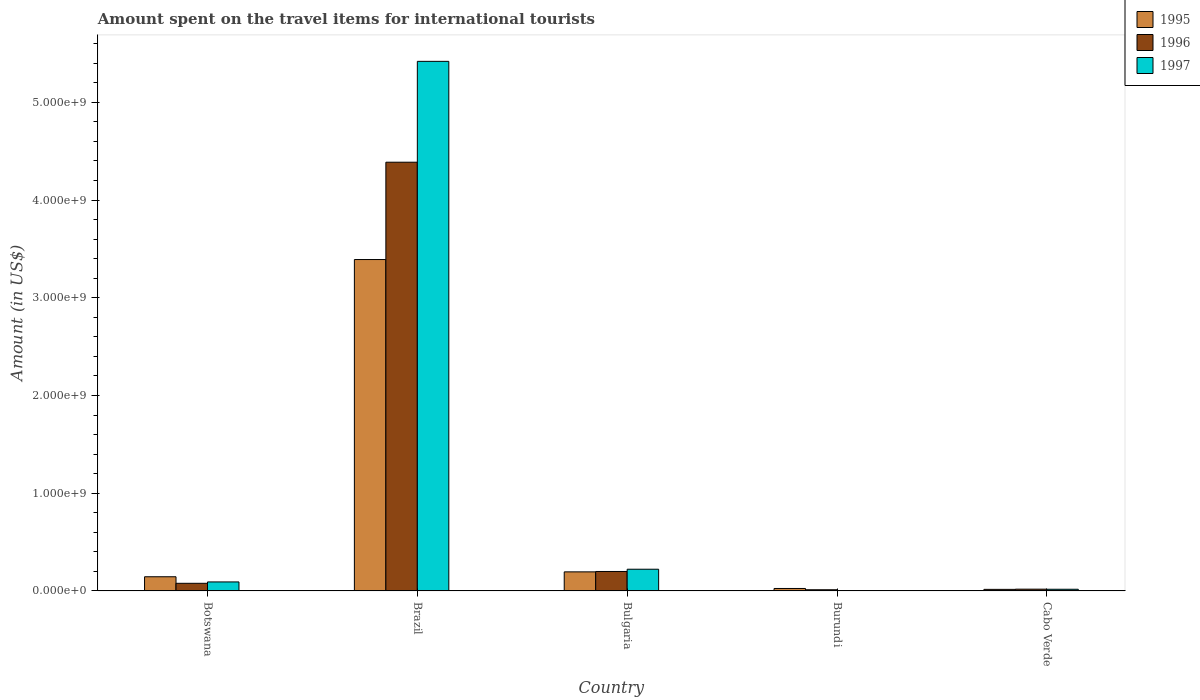How many different coloured bars are there?
Keep it short and to the point. 3. Are the number of bars on each tick of the X-axis equal?
Keep it short and to the point. Yes. How many bars are there on the 4th tick from the left?
Offer a terse response. 3. What is the label of the 4th group of bars from the left?
Offer a terse response. Burundi. In how many cases, is the number of bars for a given country not equal to the number of legend labels?
Make the answer very short. 0. What is the amount spent on the travel items for international tourists in 1996 in Burundi?
Provide a short and direct response. 1.20e+07. Across all countries, what is the maximum amount spent on the travel items for international tourists in 1997?
Your response must be concise. 5.42e+09. In which country was the amount spent on the travel items for international tourists in 1996 minimum?
Make the answer very short. Burundi. What is the total amount spent on the travel items for international tourists in 1997 in the graph?
Ensure brevity in your answer.  5.75e+09. What is the difference between the amount spent on the travel items for international tourists in 1996 in Botswana and that in Bulgaria?
Provide a succinct answer. -1.21e+08. What is the difference between the amount spent on the travel items for international tourists in 1995 in Burundi and the amount spent on the travel items for international tourists in 1997 in Botswana?
Your response must be concise. -6.70e+07. What is the average amount spent on the travel items for international tourists in 1995 per country?
Your answer should be very brief. 7.54e+08. What is the difference between the amount spent on the travel items for international tourists of/in 1997 and amount spent on the travel items for international tourists of/in 1996 in Bulgaria?
Offer a terse response. 2.30e+07. In how many countries, is the amount spent on the travel items for international tourists in 1995 greater than 2200000000 US$?
Offer a terse response. 1. What is the ratio of the amount spent on the travel items for international tourists in 1995 in Brazil to that in Burundi?
Provide a short and direct response. 135.64. Is the difference between the amount spent on the travel items for international tourists in 1997 in Brazil and Bulgaria greater than the difference between the amount spent on the travel items for international tourists in 1996 in Brazil and Bulgaria?
Provide a short and direct response. Yes. What is the difference between the highest and the second highest amount spent on the travel items for international tourists in 1995?
Your answer should be very brief. 3.25e+09. What is the difference between the highest and the lowest amount spent on the travel items for international tourists in 1995?
Provide a succinct answer. 3.38e+09. In how many countries, is the amount spent on the travel items for international tourists in 1995 greater than the average amount spent on the travel items for international tourists in 1995 taken over all countries?
Your answer should be compact. 1. What does the 3rd bar from the left in Cabo Verde represents?
Your answer should be compact. 1997. What does the 2nd bar from the right in Cabo Verde represents?
Offer a terse response. 1996. Is it the case that in every country, the sum of the amount spent on the travel items for international tourists in 1997 and amount spent on the travel items for international tourists in 1996 is greater than the amount spent on the travel items for international tourists in 1995?
Your answer should be compact. No. How many bars are there?
Your response must be concise. 15. Are all the bars in the graph horizontal?
Your answer should be very brief. No. How many countries are there in the graph?
Provide a short and direct response. 5. What is the difference between two consecutive major ticks on the Y-axis?
Ensure brevity in your answer.  1.00e+09. Does the graph contain grids?
Offer a very short reply. No. How are the legend labels stacked?
Keep it short and to the point. Vertical. What is the title of the graph?
Offer a very short reply. Amount spent on the travel items for international tourists. Does "2010" appear as one of the legend labels in the graph?
Offer a very short reply. No. What is the label or title of the Y-axis?
Offer a very short reply. Amount (in US$). What is the Amount (in US$) in 1995 in Botswana?
Your answer should be compact. 1.45e+08. What is the Amount (in US$) of 1996 in Botswana?
Provide a succinct answer. 7.80e+07. What is the Amount (in US$) of 1997 in Botswana?
Ensure brevity in your answer.  9.20e+07. What is the Amount (in US$) of 1995 in Brazil?
Give a very brief answer. 3.39e+09. What is the Amount (in US$) in 1996 in Brazil?
Make the answer very short. 4.39e+09. What is the Amount (in US$) in 1997 in Brazil?
Your answer should be very brief. 5.42e+09. What is the Amount (in US$) in 1995 in Bulgaria?
Offer a terse response. 1.95e+08. What is the Amount (in US$) in 1996 in Bulgaria?
Give a very brief answer. 1.99e+08. What is the Amount (in US$) of 1997 in Bulgaria?
Ensure brevity in your answer.  2.22e+08. What is the Amount (in US$) in 1995 in Burundi?
Offer a very short reply. 2.50e+07. What is the Amount (in US$) of 1996 in Burundi?
Provide a succinct answer. 1.20e+07. What is the Amount (in US$) in 1997 in Burundi?
Your response must be concise. 4.00e+06. What is the Amount (in US$) of 1995 in Cabo Verde?
Provide a short and direct response. 1.60e+07. What is the Amount (in US$) of 1996 in Cabo Verde?
Your answer should be compact. 1.80e+07. What is the Amount (in US$) of 1997 in Cabo Verde?
Make the answer very short. 1.70e+07. Across all countries, what is the maximum Amount (in US$) of 1995?
Your answer should be very brief. 3.39e+09. Across all countries, what is the maximum Amount (in US$) of 1996?
Make the answer very short. 4.39e+09. Across all countries, what is the maximum Amount (in US$) in 1997?
Keep it short and to the point. 5.42e+09. Across all countries, what is the minimum Amount (in US$) of 1995?
Offer a terse response. 1.60e+07. Across all countries, what is the minimum Amount (in US$) in 1996?
Your response must be concise. 1.20e+07. What is the total Amount (in US$) in 1995 in the graph?
Offer a very short reply. 3.77e+09. What is the total Amount (in US$) of 1996 in the graph?
Ensure brevity in your answer.  4.69e+09. What is the total Amount (in US$) in 1997 in the graph?
Keep it short and to the point. 5.75e+09. What is the difference between the Amount (in US$) in 1995 in Botswana and that in Brazil?
Your answer should be compact. -3.25e+09. What is the difference between the Amount (in US$) of 1996 in Botswana and that in Brazil?
Ensure brevity in your answer.  -4.31e+09. What is the difference between the Amount (in US$) in 1997 in Botswana and that in Brazil?
Offer a very short reply. -5.33e+09. What is the difference between the Amount (in US$) in 1995 in Botswana and that in Bulgaria?
Offer a very short reply. -5.00e+07. What is the difference between the Amount (in US$) in 1996 in Botswana and that in Bulgaria?
Provide a short and direct response. -1.21e+08. What is the difference between the Amount (in US$) of 1997 in Botswana and that in Bulgaria?
Your answer should be compact. -1.30e+08. What is the difference between the Amount (in US$) of 1995 in Botswana and that in Burundi?
Provide a short and direct response. 1.20e+08. What is the difference between the Amount (in US$) in 1996 in Botswana and that in Burundi?
Provide a short and direct response. 6.60e+07. What is the difference between the Amount (in US$) in 1997 in Botswana and that in Burundi?
Provide a succinct answer. 8.80e+07. What is the difference between the Amount (in US$) in 1995 in Botswana and that in Cabo Verde?
Your answer should be compact. 1.29e+08. What is the difference between the Amount (in US$) of 1996 in Botswana and that in Cabo Verde?
Give a very brief answer. 6.00e+07. What is the difference between the Amount (in US$) in 1997 in Botswana and that in Cabo Verde?
Your response must be concise. 7.50e+07. What is the difference between the Amount (in US$) of 1995 in Brazil and that in Bulgaria?
Provide a short and direct response. 3.20e+09. What is the difference between the Amount (in US$) in 1996 in Brazil and that in Bulgaria?
Your answer should be compact. 4.19e+09. What is the difference between the Amount (in US$) in 1997 in Brazil and that in Bulgaria?
Make the answer very short. 5.20e+09. What is the difference between the Amount (in US$) in 1995 in Brazil and that in Burundi?
Your answer should be very brief. 3.37e+09. What is the difference between the Amount (in US$) in 1996 in Brazil and that in Burundi?
Your response must be concise. 4.38e+09. What is the difference between the Amount (in US$) in 1997 in Brazil and that in Burundi?
Your response must be concise. 5.42e+09. What is the difference between the Amount (in US$) of 1995 in Brazil and that in Cabo Verde?
Offer a very short reply. 3.38e+09. What is the difference between the Amount (in US$) in 1996 in Brazil and that in Cabo Verde?
Make the answer very short. 4.37e+09. What is the difference between the Amount (in US$) in 1997 in Brazil and that in Cabo Verde?
Provide a succinct answer. 5.40e+09. What is the difference between the Amount (in US$) in 1995 in Bulgaria and that in Burundi?
Provide a short and direct response. 1.70e+08. What is the difference between the Amount (in US$) of 1996 in Bulgaria and that in Burundi?
Make the answer very short. 1.87e+08. What is the difference between the Amount (in US$) in 1997 in Bulgaria and that in Burundi?
Provide a succinct answer. 2.18e+08. What is the difference between the Amount (in US$) in 1995 in Bulgaria and that in Cabo Verde?
Make the answer very short. 1.79e+08. What is the difference between the Amount (in US$) of 1996 in Bulgaria and that in Cabo Verde?
Keep it short and to the point. 1.81e+08. What is the difference between the Amount (in US$) in 1997 in Bulgaria and that in Cabo Verde?
Provide a short and direct response. 2.05e+08. What is the difference between the Amount (in US$) in 1995 in Burundi and that in Cabo Verde?
Keep it short and to the point. 9.00e+06. What is the difference between the Amount (in US$) of 1996 in Burundi and that in Cabo Verde?
Offer a terse response. -6.00e+06. What is the difference between the Amount (in US$) in 1997 in Burundi and that in Cabo Verde?
Provide a short and direct response. -1.30e+07. What is the difference between the Amount (in US$) of 1995 in Botswana and the Amount (in US$) of 1996 in Brazil?
Give a very brief answer. -4.24e+09. What is the difference between the Amount (in US$) of 1995 in Botswana and the Amount (in US$) of 1997 in Brazil?
Ensure brevity in your answer.  -5.27e+09. What is the difference between the Amount (in US$) of 1996 in Botswana and the Amount (in US$) of 1997 in Brazil?
Your answer should be very brief. -5.34e+09. What is the difference between the Amount (in US$) of 1995 in Botswana and the Amount (in US$) of 1996 in Bulgaria?
Keep it short and to the point. -5.40e+07. What is the difference between the Amount (in US$) of 1995 in Botswana and the Amount (in US$) of 1997 in Bulgaria?
Provide a succinct answer. -7.70e+07. What is the difference between the Amount (in US$) of 1996 in Botswana and the Amount (in US$) of 1997 in Bulgaria?
Your answer should be very brief. -1.44e+08. What is the difference between the Amount (in US$) of 1995 in Botswana and the Amount (in US$) of 1996 in Burundi?
Your answer should be compact. 1.33e+08. What is the difference between the Amount (in US$) of 1995 in Botswana and the Amount (in US$) of 1997 in Burundi?
Provide a short and direct response. 1.41e+08. What is the difference between the Amount (in US$) of 1996 in Botswana and the Amount (in US$) of 1997 in Burundi?
Make the answer very short. 7.40e+07. What is the difference between the Amount (in US$) in 1995 in Botswana and the Amount (in US$) in 1996 in Cabo Verde?
Offer a terse response. 1.27e+08. What is the difference between the Amount (in US$) of 1995 in Botswana and the Amount (in US$) of 1997 in Cabo Verde?
Keep it short and to the point. 1.28e+08. What is the difference between the Amount (in US$) in 1996 in Botswana and the Amount (in US$) in 1997 in Cabo Verde?
Make the answer very short. 6.10e+07. What is the difference between the Amount (in US$) in 1995 in Brazil and the Amount (in US$) in 1996 in Bulgaria?
Keep it short and to the point. 3.19e+09. What is the difference between the Amount (in US$) of 1995 in Brazil and the Amount (in US$) of 1997 in Bulgaria?
Provide a succinct answer. 3.17e+09. What is the difference between the Amount (in US$) of 1996 in Brazil and the Amount (in US$) of 1997 in Bulgaria?
Offer a terse response. 4.16e+09. What is the difference between the Amount (in US$) in 1995 in Brazil and the Amount (in US$) in 1996 in Burundi?
Keep it short and to the point. 3.38e+09. What is the difference between the Amount (in US$) of 1995 in Brazil and the Amount (in US$) of 1997 in Burundi?
Give a very brief answer. 3.39e+09. What is the difference between the Amount (in US$) in 1996 in Brazil and the Amount (in US$) in 1997 in Burundi?
Give a very brief answer. 4.38e+09. What is the difference between the Amount (in US$) in 1995 in Brazil and the Amount (in US$) in 1996 in Cabo Verde?
Your answer should be compact. 3.37e+09. What is the difference between the Amount (in US$) in 1995 in Brazil and the Amount (in US$) in 1997 in Cabo Verde?
Provide a succinct answer. 3.37e+09. What is the difference between the Amount (in US$) in 1996 in Brazil and the Amount (in US$) in 1997 in Cabo Verde?
Offer a terse response. 4.37e+09. What is the difference between the Amount (in US$) in 1995 in Bulgaria and the Amount (in US$) in 1996 in Burundi?
Make the answer very short. 1.83e+08. What is the difference between the Amount (in US$) of 1995 in Bulgaria and the Amount (in US$) of 1997 in Burundi?
Provide a succinct answer. 1.91e+08. What is the difference between the Amount (in US$) of 1996 in Bulgaria and the Amount (in US$) of 1997 in Burundi?
Offer a very short reply. 1.95e+08. What is the difference between the Amount (in US$) in 1995 in Bulgaria and the Amount (in US$) in 1996 in Cabo Verde?
Keep it short and to the point. 1.77e+08. What is the difference between the Amount (in US$) of 1995 in Bulgaria and the Amount (in US$) of 1997 in Cabo Verde?
Provide a succinct answer. 1.78e+08. What is the difference between the Amount (in US$) of 1996 in Bulgaria and the Amount (in US$) of 1997 in Cabo Verde?
Ensure brevity in your answer.  1.82e+08. What is the difference between the Amount (in US$) of 1996 in Burundi and the Amount (in US$) of 1997 in Cabo Verde?
Make the answer very short. -5.00e+06. What is the average Amount (in US$) in 1995 per country?
Give a very brief answer. 7.54e+08. What is the average Amount (in US$) of 1996 per country?
Your response must be concise. 9.39e+08. What is the average Amount (in US$) of 1997 per country?
Your answer should be compact. 1.15e+09. What is the difference between the Amount (in US$) in 1995 and Amount (in US$) in 1996 in Botswana?
Keep it short and to the point. 6.70e+07. What is the difference between the Amount (in US$) of 1995 and Amount (in US$) of 1997 in Botswana?
Provide a succinct answer. 5.30e+07. What is the difference between the Amount (in US$) in 1996 and Amount (in US$) in 1997 in Botswana?
Provide a succinct answer. -1.40e+07. What is the difference between the Amount (in US$) of 1995 and Amount (in US$) of 1996 in Brazil?
Your answer should be compact. -9.96e+08. What is the difference between the Amount (in US$) in 1995 and Amount (in US$) in 1997 in Brazil?
Your answer should be compact. -2.03e+09. What is the difference between the Amount (in US$) of 1996 and Amount (in US$) of 1997 in Brazil?
Give a very brief answer. -1.03e+09. What is the difference between the Amount (in US$) in 1995 and Amount (in US$) in 1996 in Bulgaria?
Your answer should be compact. -4.00e+06. What is the difference between the Amount (in US$) of 1995 and Amount (in US$) of 1997 in Bulgaria?
Your answer should be very brief. -2.70e+07. What is the difference between the Amount (in US$) in 1996 and Amount (in US$) in 1997 in Bulgaria?
Offer a terse response. -2.30e+07. What is the difference between the Amount (in US$) of 1995 and Amount (in US$) of 1996 in Burundi?
Provide a short and direct response. 1.30e+07. What is the difference between the Amount (in US$) in 1995 and Amount (in US$) in 1997 in Burundi?
Offer a very short reply. 2.10e+07. What is the difference between the Amount (in US$) in 1995 and Amount (in US$) in 1996 in Cabo Verde?
Keep it short and to the point. -2.00e+06. What is the difference between the Amount (in US$) in 1996 and Amount (in US$) in 1997 in Cabo Verde?
Ensure brevity in your answer.  1.00e+06. What is the ratio of the Amount (in US$) in 1995 in Botswana to that in Brazil?
Offer a terse response. 0.04. What is the ratio of the Amount (in US$) of 1996 in Botswana to that in Brazil?
Make the answer very short. 0.02. What is the ratio of the Amount (in US$) in 1997 in Botswana to that in Brazil?
Provide a short and direct response. 0.02. What is the ratio of the Amount (in US$) in 1995 in Botswana to that in Bulgaria?
Ensure brevity in your answer.  0.74. What is the ratio of the Amount (in US$) in 1996 in Botswana to that in Bulgaria?
Your answer should be very brief. 0.39. What is the ratio of the Amount (in US$) of 1997 in Botswana to that in Bulgaria?
Offer a terse response. 0.41. What is the ratio of the Amount (in US$) in 1995 in Botswana to that in Burundi?
Give a very brief answer. 5.8. What is the ratio of the Amount (in US$) in 1997 in Botswana to that in Burundi?
Give a very brief answer. 23. What is the ratio of the Amount (in US$) in 1995 in Botswana to that in Cabo Verde?
Ensure brevity in your answer.  9.06. What is the ratio of the Amount (in US$) in 1996 in Botswana to that in Cabo Verde?
Provide a short and direct response. 4.33. What is the ratio of the Amount (in US$) in 1997 in Botswana to that in Cabo Verde?
Provide a short and direct response. 5.41. What is the ratio of the Amount (in US$) of 1995 in Brazil to that in Bulgaria?
Keep it short and to the point. 17.39. What is the ratio of the Amount (in US$) of 1996 in Brazil to that in Bulgaria?
Offer a terse response. 22.05. What is the ratio of the Amount (in US$) of 1997 in Brazil to that in Bulgaria?
Offer a very short reply. 24.41. What is the ratio of the Amount (in US$) in 1995 in Brazil to that in Burundi?
Ensure brevity in your answer.  135.64. What is the ratio of the Amount (in US$) of 1996 in Brazil to that in Burundi?
Your response must be concise. 365.58. What is the ratio of the Amount (in US$) in 1997 in Brazil to that in Burundi?
Your answer should be very brief. 1354.75. What is the ratio of the Amount (in US$) of 1995 in Brazil to that in Cabo Verde?
Provide a short and direct response. 211.94. What is the ratio of the Amount (in US$) of 1996 in Brazil to that in Cabo Verde?
Ensure brevity in your answer.  243.72. What is the ratio of the Amount (in US$) of 1997 in Brazil to that in Cabo Verde?
Your answer should be compact. 318.76. What is the ratio of the Amount (in US$) of 1996 in Bulgaria to that in Burundi?
Keep it short and to the point. 16.58. What is the ratio of the Amount (in US$) in 1997 in Bulgaria to that in Burundi?
Provide a succinct answer. 55.5. What is the ratio of the Amount (in US$) of 1995 in Bulgaria to that in Cabo Verde?
Keep it short and to the point. 12.19. What is the ratio of the Amount (in US$) in 1996 in Bulgaria to that in Cabo Verde?
Offer a very short reply. 11.06. What is the ratio of the Amount (in US$) in 1997 in Bulgaria to that in Cabo Verde?
Give a very brief answer. 13.06. What is the ratio of the Amount (in US$) in 1995 in Burundi to that in Cabo Verde?
Offer a very short reply. 1.56. What is the ratio of the Amount (in US$) of 1997 in Burundi to that in Cabo Verde?
Ensure brevity in your answer.  0.24. What is the difference between the highest and the second highest Amount (in US$) of 1995?
Give a very brief answer. 3.20e+09. What is the difference between the highest and the second highest Amount (in US$) in 1996?
Keep it short and to the point. 4.19e+09. What is the difference between the highest and the second highest Amount (in US$) in 1997?
Ensure brevity in your answer.  5.20e+09. What is the difference between the highest and the lowest Amount (in US$) in 1995?
Ensure brevity in your answer.  3.38e+09. What is the difference between the highest and the lowest Amount (in US$) of 1996?
Give a very brief answer. 4.38e+09. What is the difference between the highest and the lowest Amount (in US$) in 1997?
Give a very brief answer. 5.42e+09. 